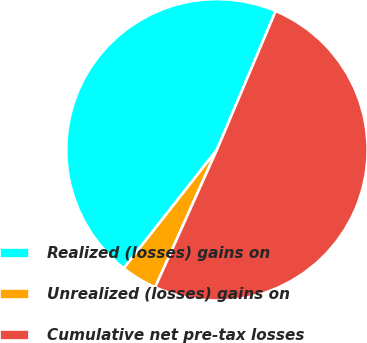<chart> <loc_0><loc_0><loc_500><loc_500><pie_chart><fcel>Realized (losses) gains on<fcel>Unrealized (losses) gains on<fcel>Cumulative net pre-tax losses<nl><fcel>45.77%<fcel>3.89%<fcel>50.35%<nl></chart> 